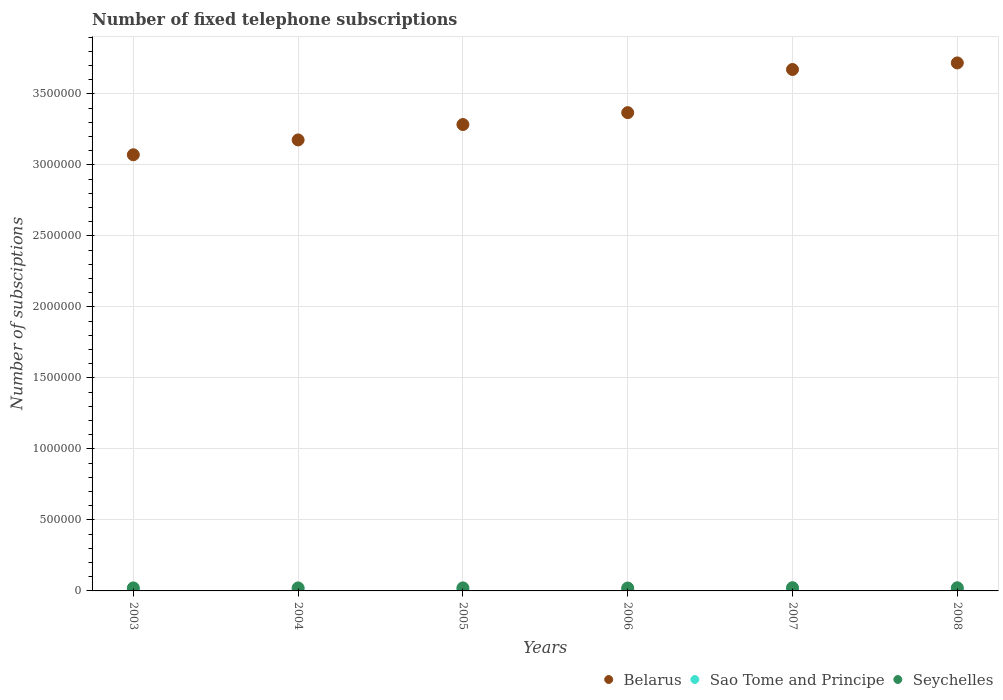How many different coloured dotlines are there?
Give a very brief answer. 3. What is the number of fixed telephone subscriptions in Seychelles in 2008?
Provide a short and direct response. 2.23e+04. Across all years, what is the maximum number of fixed telephone subscriptions in Seychelles?
Give a very brief answer. 2.27e+04. Across all years, what is the minimum number of fixed telephone subscriptions in Seychelles?
Your answer should be compact. 2.07e+04. What is the total number of fixed telephone subscriptions in Seychelles in the graph?
Provide a short and direct response. 1.30e+05. What is the difference between the number of fixed telephone subscriptions in Sao Tome and Principe in 2004 and that in 2005?
Your answer should be very brief. -62. What is the difference between the number of fixed telephone subscriptions in Belarus in 2008 and the number of fixed telephone subscriptions in Sao Tome and Principe in 2007?
Your answer should be compact. 3.71e+06. What is the average number of fixed telephone subscriptions in Sao Tome and Principe per year?
Provide a short and direct response. 7337. In the year 2005, what is the difference between the number of fixed telephone subscriptions in Sao Tome and Principe and number of fixed telephone subscriptions in Seychelles?
Provide a succinct answer. -1.43e+04. In how many years, is the number of fixed telephone subscriptions in Sao Tome and Principe greater than 2200000?
Your answer should be compact. 0. What is the ratio of the number of fixed telephone subscriptions in Belarus in 2005 to that in 2008?
Provide a succinct answer. 0.88. Is the number of fixed telephone subscriptions in Belarus in 2005 less than that in 2006?
Offer a very short reply. Yes. Is the difference between the number of fixed telephone subscriptions in Sao Tome and Principe in 2006 and 2008 greater than the difference between the number of fixed telephone subscriptions in Seychelles in 2006 and 2008?
Your answer should be compact. Yes. What is the difference between the highest and the second highest number of fixed telephone subscriptions in Sao Tome and Principe?
Keep it short and to the point. 11. What is the difference between the highest and the lowest number of fixed telephone subscriptions in Sao Tome and Principe?
Your response must be concise. 684. Is the sum of the number of fixed telephone subscriptions in Seychelles in 2005 and 2006 greater than the maximum number of fixed telephone subscriptions in Belarus across all years?
Offer a very short reply. No. Does the number of fixed telephone subscriptions in Sao Tome and Principe monotonically increase over the years?
Ensure brevity in your answer.  No. Is the number of fixed telephone subscriptions in Sao Tome and Principe strictly less than the number of fixed telephone subscriptions in Seychelles over the years?
Your response must be concise. Yes. How many dotlines are there?
Give a very brief answer. 3. How many years are there in the graph?
Make the answer very short. 6. Are the values on the major ticks of Y-axis written in scientific E-notation?
Provide a succinct answer. No. Does the graph contain any zero values?
Ensure brevity in your answer.  No. Does the graph contain grids?
Give a very brief answer. Yes. Where does the legend appear in the graph?
Offer a very short reply. Bottom right. How many legend labels are there?
Offer a very short reply. 3. How are the legend labels stacked?
Offer a very short reply. Horizontal. What is the title of the graph?
Offer a terse response. Number of fixed telephone subscriptions. What is the label or title of the X-axis?
Provide a succinct answer. Years. What is the label or title of the Y-axis?
Ensure brevity in your answer.  Number of subsciptions. What is the Number of subsciptions in Belarus in 2003?
Your answer should be very brief. 3.07e+06. What is the Number of subsciptions in Sao Tome and Principe in 2003?
Your response must be concise. 6970. What is the Number of subsciptions in Seychelles in 2003?
Provide a succinct answer. 2.12e+04. What is the Number of subsciptions of Belarus in 2004?
Your answer should be compact. 3.18e+06. What is the Number of subsciptions of Sao Tome and Principe in 2004?
Your response must be concise. 7050. What is the Number of subsciptions of Seychelles in 2004?
Keep it short and to the point. 2.13e+04. What is the Number of subsciptions of Belarus in 2005?
Your answer should be compact. 3.28e+06. What is the Number of subsciptions of Sao Tome and Principe in 2005?
Your answer should be compact. 7112. What is the Number of subsciptions of Seychelles in 2005?
Your answer should be very brief. 2.14e+04. What is the Number of subsciptions of Belarus in 2006?
Make the answer very short. 3.37e+06. What is the Number of subsciptions in Sao Tome and Principe in 2006?
Offer a terse response. 7593. What is the Number of subsciptions of Seychelles in 2006?
Provide a short and direct response. 2.07e+04. What is the Number of subsciptions in Belarus in 2007?
Give a very brief answer. 3.67e+06. What is the Number of subsciptions in Sao Tome and Principe in 2007?
Keep it short and to the point. 7654. What is the Number of subsciptions in Seychelles in 2007?
Your answer should be compact. 2.27e+04. What is the Number of subsciptions in Belarus in 2008?
Offer a very short reply. 3.72e+06. What is the Number of subsciptions of Sao Tome and Principe in 2008?
Your response must be concise. 7643. What is the Number of subsciptions of Seychelles in 2008?
Your answer should be compact. 2.23e+04. Across all years, what is the maximum Number of subsciptions in Belarus?
Your response must be concise. 3.72e+06. Across all years, what is the maximum Number of subsciptions of Sao Tome and Principe?
Ensure brevity in your answer.  7654. Across all years, what is the maximum Number of subsciptions in Seychelles?
Keep it short and to the point. 2.27e+04. Across all years, what is the minimum Number of subsciptions of Belarus?
Keep it short and to the point. 3.07e+06. Across all years, what is the minimum Number of subsciptions in Sao Tome and Principe?
Provide a succinct answer. 6970. Across all years, what is the minimum Number of subsciptions of Seychelles?
Give a very brief answer. 2.07e+04. What is the total Number of subsciptions of Belarus in the graph?
Your answer should be compact. 2.03e+07. What is the total Number of subsciptions of Sao Tome and Principe in the graph?
Make the answer very short. 4.40e+04. What is the total Number of subsciptions of Seychelles in the graph?
Provide a succinct answer. 1.30e+05. What is the difference between the Number of subsciptions in Belarus in 2003 and that in 2004?
Provide a succinct answer. -1.05e+05. What is the difference between the Number of subsciptions in Sao Tome and Principe in 2003 and that in 2004?
Offer a terse response. -80. What is the difference between the Number of subsciptions in Seychelles in 2003 and that in 2004?
Offer a terse response. -77. What is the difference between the Number of subsciptions of Belarus in 2003 and that in 2005?
Provide a short and direct response. -2.13e+05. What is the difference between the Number of subsciptions in Sao Tome and Principe in 2003 and that in 2005?
Your response must be concise. -142. What is the difference between the Number of subsciptions of Seychelles in 2003 and that in 2005?
Offer a very short reply. -213. What is the difference between the Number of subsciptions of Belarus in 2003 and that in 2006?
Provide a short and direct response. -2.97e+05. What is the difference between the Number of subsciptions in Sao Tome and Principe in 2003 and that in 2006?
Your answer should be very brief. -623. What is the difference between the Number of subsciptions in Seychelles in 2003 and that in 2006?
Offer a very short reply. 512. What is the difference between the Number of subsciptions in Belarus in 2003 and that in 2007?
Give a very brief answer. -6.01e+05. What is the difference between the Number of subsciptions in Sao Tome and Principe in 2003 and that in 2007?
Offer a very short reply. -684. What is the difference between the Number of subsciptions in Seychelles in 2003 and that in 2007?
Make the answer very short. -1531. What is the difference between the Number of subsciptions of Belarus in 2003 and that in 2008?
Provide a short and direct response. -6.47e+05. What is the difference between the Number of subsciptions in Sao Tome and Principe in 2003 and that in 2008?
Provide a short and direct response. -673. What is the difference between the Number of subsciptions of Seychelles in 2003 and that in 2008?
Give a very brief answer. -1131. What is the difference between the Number of subsciptions in Belarus in 2004 and that in 2005?
Provide a short and direct response. -1.08e+05. What is the difference between the Number of subsciptions of Sao Tome and Principe in 2004 and that in 2005?
Your answer should be very brief. -62. What is the difference between the Number of subsciptions of Seychelles in 2004 and that in 2005?
Give a very brief answer. -136. What is the difference between the Number of subsciptions of Belarus in 2004 and that in 2006?
Make the answer very short. -1.92e+05. What is the difference between the Number of subsciptions of Sao Tome and Principe in 2004 and that in 2006?
Your response must be concise. -543. What is the difference between the Number of subsciptions in Seychelles in 2004 and that in 2006?
Your response must be concise. 589. What is the difference between the Number of subsciptions in Belarus in 2004 and that in 2007?
Offer a terse response. -4.96e+05. What is the difference between the Number of subsciptions of Sao Tome and Principe in 2004 and that in 2007?
Give a very brief answer. -604. What is the difference between the Number of subsciptions in Seychelles in 2004 and that in 2007?
Give a very brief answer. -1454. What is the difference between the Number of subsciptions of Belarus in 2004 and that in 2008?
Your answer should be compact. -5.42e+05. What is the difference between the Number of subsciptions of Sao Tome and Principe in 2004 and that in 2008?
Your answer should be very brief. -593. What is the difference between the Number of subsciptions in Seychelles in 2004 and that in 2008?
Provide a succinct answer. -1054. What is the difference between the Number of subsciptions in Belarus in 2005 and that in 2006?
Offer a very short reply. -8.37e+04. What is the difference between the Number of subsciptions in Sao Tome and Principe in 2005 and that in 2006?
Your answer should be compact. -481. What is the difference between the Number of subsciptions of Seychelles in 2005 and that in 2006?
Provide a succinct answer. 725. What is the difference between the Number of subsciptions in Belarus in 2005 and that in 2007?
Your answer should be compact. -3.88e+05. What is the difference between the Number of subsciptions in Sao Tome and Principe in 2005 and that in 2007?
Offer a terse response. -542. What is the difference between the Number of subsciptions in Seychelles in 2005 and that in 2007?
Give a very brief answer. -1318. What is the difference between the Number of subsciptions of Belarus in 2005 and that in 2008?
Make the answer very short. -4.34e+05. What is the difference between the Number of subsciptions in Sao Tome and Principe in 2005 and that in 2008?
Ensure brevity in your answer.  -531. What is the difference between the Number of subsciptions of Seychelles in 2005 and that in 2008?
Make the answer very short. -918. What is the difference between the Number of subsciptions of Belarus in 2006 and that in 2007?
Your answer should be very brief. -3.04e+05. What is the difference between the Number of subsciptions of Sao Tome and Principe in 2006 and that in 2007?
Keep it short and to the point. -61. What is the difference between the Number of subsciptions of Seychelles in 2006 and that in 2007?
Ensure brevity in your answer.  -2043. What is the difference between the Number of subsciptions in Belarus in 2006 and that in 2008?
Offer a terse response. -3.50e+05. What is the difference between the Number of subsciptions of Seychelles in 2006 and that in 2008?
Offer a very short reply. -1643. What is the difference between the Number of subsciptions of Belarus in 2007 and that in 2008?
Keep it short and to the point. -4.62e+04. What is the difference between the Number of subsciptions of Sao Tome and Principe in 2007 and that in 2008?
Your response must be concise. 11. What is the difference between the Number of subsciptions in Belarus in 2003 and the Number of subsciptions in Sao Tome and Principe in 2004?
Your answer should be very brief. 3.06e+06. What is the difference between the Number of subsciptions of Belarus in 2003 and the Number of subsciptions of Seychelles in 2004?
Provide a succinct answer. 3.05e+06. What is the difference between the Number of subsciptions of Sao Tome and Principe in 2003 and the Number of subsciptions of Seychelles in 2004?
Make the answer very short. -1.43e+04. What is the difference between the Number of subsciptions in Belarus in 2003 and the Number of subsciptions in Sao Tome and Principe in 2005?
Keep it short and to the point. 3.06e+06. What is the difference between the Number of subsciptions of Belarus in 2003 and the Number of subsciptions of Seychelles in 2005?
Give a very brief answer. 3.05e+06. What is the difference between the Number of subsciptions in Sao Tome and Principe in 2003 and the Number of subsciptions in Seychelles in 2005?
Offer a terse response. -1.44e+04. What is the difference between the Number of subsciptions in Belarus in 2003 and the Number of subsciptions in Sao Tome and Principe in 2006?
Make the answer very short. 3.06e+06. What is the difference between the Number of subsciptions of Belarus in 2003 and the Number of subsciptions of Seychelles in 2006?
Provide a succinct answer. 3.05e+06. What is the difference between the Number of subsciptions in Sao Tome and Principe in 2003 and the Number of subsciptions in Seychelles in 2006?
Offer a terse response. -1.37e+04. What is the difference between the Number of subsciptions in Belarus in 2003 and the Number of subsciptions in Sao Tome and Principe in 2007?
Offer a very short reply. 3.06e+06. What is the difference between the Number of subsciptions of Belarus in 2003 and the Number of subsciptions of Seychelles in 2007?
Your response must be concise. 3.05e+06. What is the difference between the Number of subsciptions in Sao Tome and Principe in 2003 and the Number of subsciptions in Seychelles in 2007?
Your answer should be very brief. -1.58e+04. What is the difference between the Number of subsciptions of Belarus in 2003 and the Number of subsciptions of Sao Tome and Principe in 2008?
Make the answer very short. 3.06e+06. What is the difference between the Number of subsciptions in Belarus in 2003 and the Number of subsciptions in Seychelles in 2008?
Offer a terse response. 3.05e+06. What is the difference between the Number of subsciptions of Sao Tome and Principe in 2003 and the Number of subsciptions of Seychelles in 2008?
Provide a short and direct response. -1.54e+04. What is the difference between the Number of subsciptions of Belarus in 2004 and the Number of subsciptions of Sao Tome and Principe in 2005?
Your answer should be very brief. 3.17e+06. What is the difference between the Number of subsciptions in Belarus in 2004 and the Number of subsciptions in Seychelles in 2005?
Make the answer very short. 3.15e+06. What is the difference between the Number of subsciptions of Sao Tome and Principe in 2004 and the Number of subsciptions of Seychelles in 2005?
Your answer should be compact. -1.44e+04. What is the difference between the Number of subsciptions in Belarus in 2004 and the Number of subsciptions in Sao Tome and Principe in 2006?
Make the answer very short. 3.17e+06. What is the difference between the Number of subsciptions of Belarus in 2004 and the Number of subsciptions of Seychelles in 2006?
Your answer should be compact. 3.16e+06. What is the difference between the Number of subsciptions in Sao Tome and Principe in 2004 and the Number of subsciptions in Seychelles in 2006?
Provide a succinct answer. -1.36e+04. What is the difference between the Number of subsciptions in Belarus in 2004 and the Number of subsciptions in Sao Tome and Principe in 2007?
Offer a very short reply. 3.17e+06. What is the difference between the Number of subsciptions of Belarus in 2004 and the Number of subsciptions of Seychelles in 2007?
Ensure brevity in your answer.  3.15e+06. What is the difference between the Number of subsciptions of Sao Tome and Principe in 2004 and the Number of subsciptions of Seychelles in 2007?
Your answer should be very brief. -1.57e+04. What is the difference between the Number of subsciptions in Belarus in 2004 and the Number of subsciptions in Sao Tome and Principe in 2008?
Make the answer very short. 3.17e+06. What is the difference between the Number of subsciptions of Belarus in 2004 and the Number of subsciptions of Seychelles in 2008?
Offer a very short reply. 3.15e+06. What is the difference between the Number of subsciptions in Sao Tome and Principe in 2004 and the Number of subsciptions in Seychelles in 2008?
Provide a short and direct response. -1.53e+04. What is the difference between the Number of subsciptions of Belarus in 2005 and the Number of subsciptions of Sao Tome and Principe in 2006?
Give a very brief answer. 3.28e+06. What is the difference between the Number of subsciptions in Belarus in 2005 and the Number of subsciptions in Seychelles in 2006?
Keep it short and to the point. 3.26e+06. What is the difference between the Number of subsciptions in Sao Tome and Principe in 2005 and the Number of subsciptions in Seychelles in 2006?
Offer a very short reply. -1.36e+04. What is the difference between the Number of subsciptions in Belarus in 2005 and the Number of subsciptions in Sao Tome and Principe in 2007?
Your answer should be compact. 3.28e+06. What is the difference between the Number of subsciptions of Belarus in 2005 and the Number of subsciptions of Seychelles in 2007?
Offer a terse response. 3.26e+06. What is the difference between the Number of subsciptions in Sao Tome and Principe in 2005 and the Number of subsciptions in Seychelles in 2007?
Offer a terse response. -1.56e+04. What is the difference between the Number of subsciptions in Belarus in 2005 and the Number of subsciptions in Sao Tome and Principe in 2008?
Make the answer very short. 3.28e+06. What is the difference between the Number of subsciptions of Belarus in 2005 and the Number of subsciptions of Seychelles in 2008?
Keep it short and to the point. 3.26e+06. What is the difference between the Number of subsciptions of Sao Tome and Principe in 2005 and the Number of subsciptions of Seychelles in 2008?
Provide a succinct answer. -1.52e+04. What is the difference between the Number of subsciptions of Belarus in 2006 and the Number of subsciptions of Sao Tome and Principe in 2007?
Your answer should be very brief. 3.36e+06. What is the difference between the Number of subsciptions of Belarus in 2006 and the Number of subsciptions of Seychelles in 2007?
Provide a short and direct response. 3.35e+06. What is the difference between the Number of subsciptions of Sao Tome and Principe in 2006 and the Number of subsciptions of Seychelles in 2007?
Give a very brief answer. -1.51e+04. What is the difference between the Number of subsciptions in Belarus in 2006 and the Number of subsciptions in Sao Tome and Principe in 2008?
Give a very brief answer. 3.36e+06. What is the difference between the Number of subsciptions of Belarus in 2006 and the Number of subsciptions of Seychelles in 2008?
Provide a short and direct response. 3.35e+06. What is the difference between the Number of subsciptions in Sao Tome and Principe in 2006 and the Number of subsciptions in Seychelles in 2008?
Your answer should be compact. -1.47e+04. What is the difference between the Number of subsciptions of Belarus in 2007 and the Number of subsciptions of Sao Tome and Principe in 2008?
Make the answer very short. 3.66e+06. What is the difference between the Number of subsciptions in Belarus in 2007 and the Number of subsciptions in Seychelles in 2008?
Keep it short and to the point. 3.65e+06. What is the difference between the Number of subsciptions in Sao Tome and Principe in 2007 and the Number of subsciptions in Seychelles in 2008?
Provide a succinct answer. -1.47e+04. What is the average Number of subsciptions in Belarus per year?
Your answer should be compact. 3.38e+06. What is the average Number of subsciptions of Sao Tome and Principe per year?
Provide a succinct answer. 7337. What is the average Number of subsciptions of Seychelles per year?
Make the answer very short. 2.16e+04. In the year 2003, what is the difference between the Number of subsciptions of Belarus and Number of subsciptions of Sao Tome and Principe?
Your response must be concise. 3.06e+06. In the year 2003, what is the difference between the Number of subsciptions of Belarus and Number of subsciptions of Seychelles?
Offer a very short reply. 3.05e+06. In the year 2003, what is the difference between the Number of subsciptions in Sao Tome and Principe and Number of subsciptions in Seychelles?
Make the answer very short. -1.42e+04. In the year 2004, what is the difference between the Number of subsciptions in Belarus and Number of subsciptions in Sao Tome and Principe?
Provide a short and direct response. 3.17e+06. In the year 2004, what is the difference between the Number of subsciptions of Belarus and Number of subsciptions of Seychelles?
Your answer should be very brief. 3.15e+06. In the year 2004, what is the difference between the Number of subsciptions of Sao Tome and Principe and Number of subsciptions of Seychelles?
Offer a very short reply. -1.42e+04. In the year 2005, what is the difference between the Number of subsciptions in Belarus and Number of subsciptions in Sao Tome and Principe?
Offer a very short reply. 3.28e+06. In the year 2005, what is the difference between the Number of subsciptions in Belarus and Number of subsciptions in Seychelles?
Provide a succinct answer. 3.26e+06. In the year 2005, what is the difference between the Number of subsciptions in Sao Tome and Principe and Number of subsciptions in Seychelles?
Offer a terse response. -1.43e+04. In the year 2006, what is the difference between the Number of subsciptions of Belarus and Number of subsciptions of Sao Tome and Principe?
Offer a terse response. 3.36e+06. In the year 2006, what is the difference between the Number of subsciptions in Belarus and Number of subsciptions in Seychelles?
Your answer should be compact. 3.35e+06. In the year 2006, what is the difference between the Number of subsciptions in Sao Tome and Principe and Number of subsciptions in Seychelles?
Give a very brief answer. -1.31e+04. In the year 2007, what is the difference between the Number of subsciptions in Belarus and Number of subsciptions in Sao Tome and Principe?
Keep it short and to the point. 3.66e+06. In the year 2007, what is the difference between the Number of subsciptions in Belarus and Number of subsciptions in Seychelles?
Provide a short and direct response. 3.65e+06. In the year 2007, what is the difference between the Number of subsciptions in Sao Tome and Principe and Number of subsciptions in Seychelles?
Make the answer very short. -1.51e+04. In the year 2008, what is the difference between the Number of subsciptions in Belarus and Number of subsciptions in Sao Tome and Principe?
Offer a terse response. 3.71e+06. In the year 2008, what is the difference between the Number of subsciptions in Belarus and Number of subsciptions in Seychelles?
Ensure brevity in your answer.  3.70e+06. In the year 2008, what is the difference between the Number of subsciptions of Sao Tome and Principe and Number of subsciptions of Seychelles?
Offer a terse response. -1.47e+04. What is the ratio of the Number of subsciptions of Belarus in 2003 to that in 2004?
Make the answer very short. 0.97. What is the ratio of the Number of subsciptions of Sao Tome and Principe in 2003 to that in 2004?
Keep it short and to the point. 0.99. What is the ratio of the Number of subsciptions in Seychelles in 2003 to that in 2004?
Keep it short and to the point. 1. What is the ratio of the Number of subsciptions of Belarus in 2003 to that in 2005?
Your response must be concise. 0.94. What is the ratio of the Number of subsciptions in Sao Tome and Principe in 2003 to that in 2005?
Offer a very short reply. 0.98. What is the ratio of the Number of subsciptions of Seychelles in 2003 to that in 2005?
Your answer should be very brief. 0.99. What is the ratio of the Number of subsciptions in Belarus in 2003 to that in 2006?
Your answer should be very brief. 0.91. What is the ratio of the Number of subsciptions in Sao Tome and Principe in 2003 to that in 2006?
Keep it short and to the point. 0.92. What is the ratio of the Number of subsciptions of Seychelles in 2003 to that in 2006?
Provide a short and direct response. 1.02. What is the ratio of the Number of subsciptions of Belarus in 2003 to that in 2007?
Keep it short and to the point. 0.84. What is the ratio of the Number of subsciptions in Sao Tome and Principe in 2003 to that in 2007?
Provide a short and direct response. 0.91. What is the ratio of the Number of subsciptions in Seychelles in 2003 to that in 2007?
Provide a succinct answer. 0.93. What is the ratio of the Number of subsciptions in Belarus in 2003 to that in 2008?
Your answer should be compact. 0.83. What is the ratio of the Number of subsciptions in Sao Tome and Principe in 2003 to that in 2008?
Give a very brief answer. 0.91. What is the ratio of the Number of subsciptions in Seychelles in 2003 to that in 2008?
Offer a terse response. 0.95. What is the ratio of the Number of subsciptions in Belarus in 2004 to that in 2005?
Give a very brief answer. 0.97. What is the ratio of the Number of subsciptions in Sao Tome and Principe in 2004 to that in 2005?
Provide a short and direct response. 0.99. What is the ratio of the Number of subsciptions of Seychelles in 2004 to that in 2005?
Offer a terse response. 0.99. What is the ratio of the Number of subsciptions in Belarus in 2004 to that in 2006?
Provide a short and direct response. 0.94. What is the ratio of the Number of subsciptions in Sao Tome and Principe in 2004 to that in 2006?
Provide a succinct answer. 0.93. What is the ratio of the Number of subsciptions of Seychelles in 2004 to that in 2006?
Make the answer very short. 1.03. What is the ratio of the Number of subsciptions of Belarus in 2004 to that in 2007?
Provide a short and direct response. 0.86. What is the ratio of the Number of subsciptions of Sao Tome and Principe in 2004 to that in 2007?
Your response must be concise. 0.92. What is the ratio of the Number of subsciptions of Seychelles in 2004 to that in 2007?
Offer a terse response. 0.94. What is the ratio of the Number of subsciptions of Belarus in 2004 to that in 2008?
Ensure brevity in your answer.  0.85. What is the ratio of the Number of subsciptions of Sao Tome and Principe in 2004 to that in 2008?
Make the answer very short. 0.92. What is the ratio of the Number of subsciptions in Seychelles in 2004 to that in 2008?
Provide a short and direct response. 0.95. What is the ratio of the Number of subsciptions in Belarus in 2005 to that in 2006?
Offer a very short reply. 0.98. What is the ratio of the Number of subsciptions of Sao Tome and Principe in 2005 to that in 2006?
Make the answer very short. 0.94. What is the ratio of the Number of subsciptions in Seychelles in 2005 to that in 2006?
Give a very brief answer. 1.04. What is the ratio of the Number of subsciptions in Belarus in 2005 to that in 2007?
Provide a short and direct response. 0.89. What is the ratio of the Number of subsciptions in Sao Tome and Principe in 2005 to that in 2007?
Your answer should be very brief. 0.93. What is the ratio of the Number of subsciptions in Seychelles in 2005 to that in 2007?
Give a very brief answer. 0.94. What is the ratio of the Number of subsciptions of Belarus in 2005 to that in 2008?
Make the answer very short. 0.88. What is the ratio of the Number of subsciptions in Sao Tome and Principe in 2005 to that in 2008?
Your response must be concise. 0.93. What is the ratio of the Number of subsciptions of Seychelles in 2005 to that in 2008?
Offer a terse response. 0.96. What is the ratio of the Number of subsciptions in Belarus in 2006 to that in 2007?
Provide a short and direct response. 0.92. What is the ratio of the Number of subsciptions of Seychelles in 2006 to that in 2007?
Your answer should be very brief. 0.91. What is the ratio of the Number of subsciptions of Belarus in 2006 to that in 2008?
Provide a short and direct response. 0.91. What is the ratio of the Number of subsciptions in Sao Tome and Principe in 2006 to that in 2008?
Your response must be concise. 0.99. What is the ratio of the Number of subsciptions in Seychelles in 2006 to that in 2008?
Your answer should be very brief. 0.93. What is the ratio of the Number of subsciptions in Belarus in 2007 to that in 2008?
Your answer should be compact. 0.99. What is the ratio of the Number of subsciptions in Seychelles in 2007 to that in 2008?
Make the answer very short. 1.02. What is the difference between the highest and the second highest Number of subsciptions of Belarus?
Offer a very short reply. 4.62e+04. What is the difference between the highest and the second highest Number of subsciptions in Sao Tome and Principe?
Your response must be concise. 11. What is the difference between the highest and the lowest Number of subsciptions of Belarus?
Provide a succinct answer. 6.47e+05. What is the difference between the highest and the lowest Number of subsciptions of Sao Tome and Principe?
Provide a succinct answer. 684. What is the difference between the highest and the lowest Number of subsciptions of Seychelles?
Your answer should be very brief. 2043. 